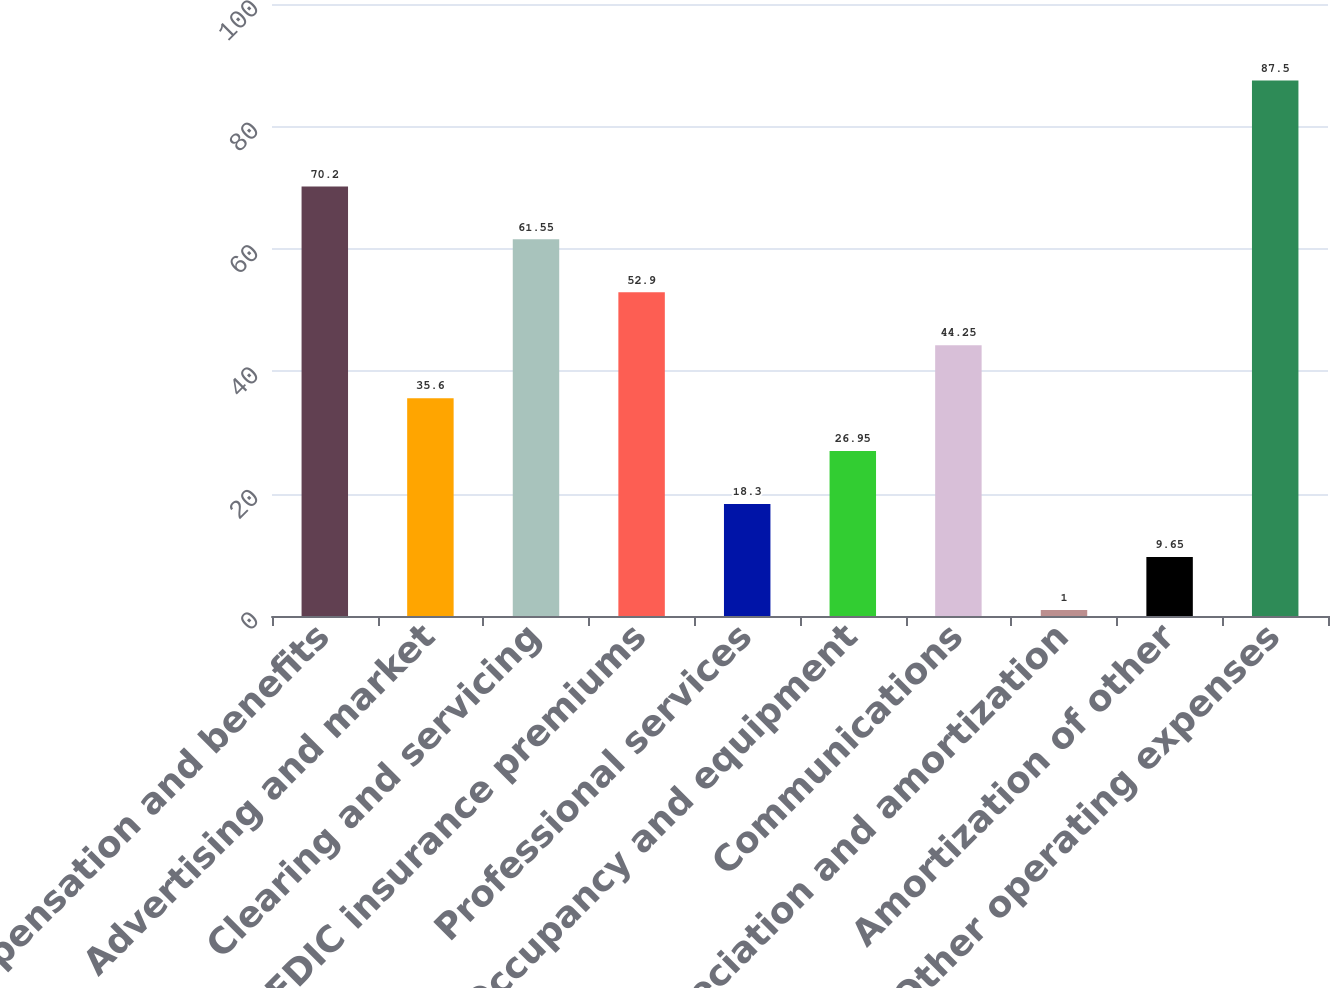Convert chart. <chart><loc_0><loc_0><loc_500><loc_500><bar_chart><fcel>Compensation and benefits<fcel>Advertising and market<fcel>Clearing and servicing<fcel>FDIC insurance premiums<fcel>Professional services<fcel>Occupancy and equipment<fcel>Communications<fcel>Depreciation and amortization<fcel>Amortization of other<fcel>Other operating expenses<nl><fcel>70.2<fcel>35.6<fcel>61.55<fcel>52.9<fcel>18.3<fcel>26.95<fcel>44.25<fcel>1<fcel>9.65<fcel>87.5<nl></chart> 